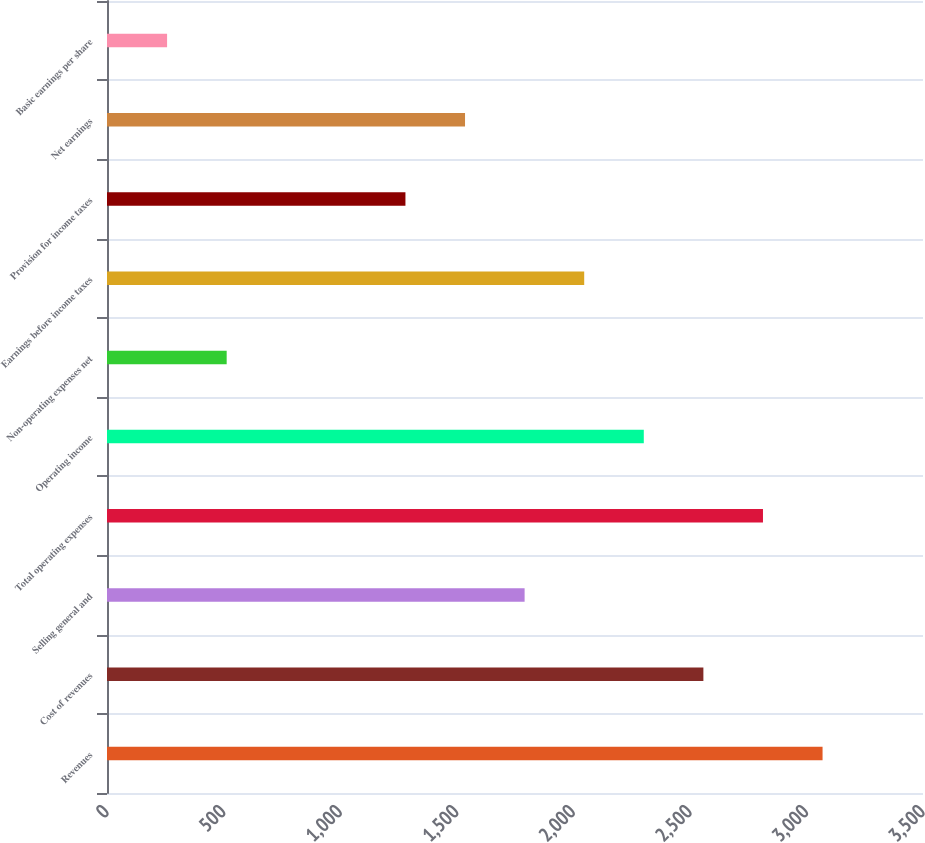Convert chart. <chart><loc_0><loc_0><loc_500><loc_500><bar_chart><fcel>Revenues<fcel>Cost of revenues<fcel>Selling general and<fcel>Total operating expenses<fcel>Operating income<fcel>Non-operating expenses net<fcel>Earnings before income taxes<fcel>Provision for income taxes<fcel>Net earnings<fcel>Basic earnings per share<nl><fcel>3069.2<fcel>2558.02<fcel>1791.25<fcel>2813.61<fcel>2302.43<fcel>513.3<fcel>2046.84<fcel>1280.07<fcel>1535.66<fcel>257.71<nl></chart> 